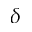Convert formula to latex. <formula><loc_0><loc_0><loc_500><loc_500>\delta</formula> 